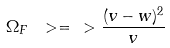Convert formula to latex. <formula><loc_0><loc_0><loc_500><loc_500>\Omega _ { F } \ > = \ > \frac { ( v - w ) ^ { 2 } } { v }</formula> 